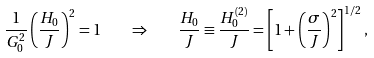<formula> <loc_0><loc_0><loc_500><loc_500>\frac { 1 } { G _ { 0 } ^ { 2 } } \left ( \frac { H _ { 0 } } { J } \right ) ^ { 2 } = 1 \quad \Rightarrow \quad \frac { H _ { 0 } } { J } \equiv \frac { H _ { 0 } ^ { ( 2 ) } } { J } = \left [ 1 + \left ( \frac { \sigma } { J } \right ) ^ { 2 } \right ] ^ { 1 / 2 } ,</formula> 